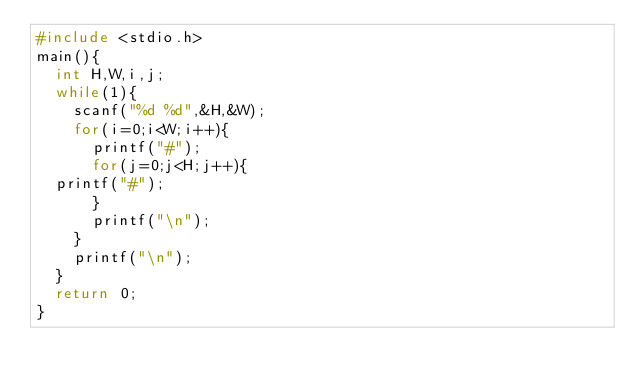<code> <loc_0><loc_0><loc_500><loc_500><_C_>#include <stdio.h>
main(){
  int H,W,i,j;
  while(1){
    scanf("%d %d",&H,&W);
    for(i=0;i<W;i++){
      printf("#");
      for(j=0;j<H;j++){
	printf("#");
      }
      printf("\n");
    }
    printf("\n");
  }
  return 0;
}</code> 